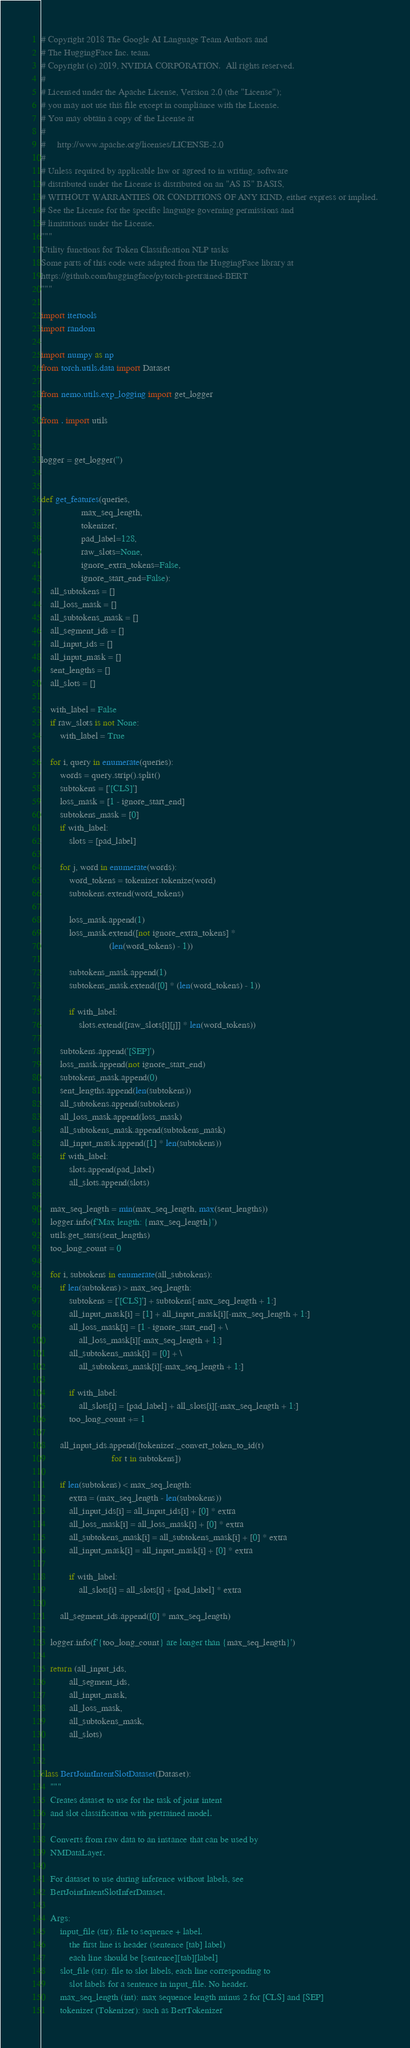<code> <loc_0><loc_0><loc_500><loc_500><_Python_># Copyright 2018 The Google AI Language Team Authors and
# The HuggingFace Inc. team.
# Copyright (c) 2019, NVIDIA CORPORATION.  All rights reserved.
#
# Licensed under the Apache License, Version 2.0 (the "License");
# you may not use this file except in compliance with the License.
# You may obtain a copy of the License at
#
#     http://www.apache.org/licenses/LICENSE-2.0
#
# Unless required by applicable law or agreed to in writing, software
# distributed under the License is distributed on an "AS IS" BASIS,
# WITHOUT WARRANTIES OR CONDITIONS OF ANY KIND, either express or implied.
# See the License for the specific language governing permissions and
# limitations under the License.
"""
Utility functions for Token Classification NLP tasks
Some parts of this code were adapted from the HuggingFace library at
https://github.com/huggingface/pytorch-pretrained-BERT
"""

import itertools
import random

import numpy as np
from torch.utils.data import Dataset

from nemo.utils.exp_logging import get_logger

from . import utils


logger = get_logger('')


def get_features(queries,
                 max_seq_length,
                 tokenizer,
                 pad_label=128,
                 raw_slots=None,
                 ignore_extra_tokens=False,
                 ignore_start_end=False):
    all_subtokens = []
    all_loss_mask = []
    all_subtokens_mask = []
    all_segment_ids = []
    all_input_ids = []
    all_input_mask = []
    sent_lengths = []
    all_slots = []

    with_label = False
    if raw_slots is not None:
        with_label = True

    for i, query in enumerate(queries):
        words = query.strip().split()
        subtokens = ['[CLS]']
        loss_mask = [1 - ignore_start_end]
        subtokens_mask = [0]
        if with_label:
            slots = [pad_label]

        for j, word in enumerate(words):
            word_tokens = tokenizer.tokenize(word)
            subtokens.extend(word_tokens)

            loss_mask.append(1)
            loss_mask.extend([not ignore_extra_tokens] *
                             (len(word_tokens) - 1))

            subtokens_mask.append(1)
            subtokens_mask.extend([0] * (len(word_tokens) - 1))

            if with_label:
                slots.extend([raw_slots[i][j]] * len(word_tokens))

        subtokens.append('[SEP]')
        loss_mask.append(not ignore_start_end)
        subtokens_mask.append(0)
        sent_lengths.append(len(subtokens))
        all_subtokens.append(subtokens)
        all_loss_mask.append(loss_mask)
        all_subtokens_mask.append(subtokens_mask)
        all_input_mask.append([1] * len(subtokens))
        if with_label:
            slots.append(pad_label)
            all_slots.append(slots)

    max_seq_length = min(max_seq_length, max(sent_lengths))
    logger.info(f'Max length: {max_seq_length}')
    utils.get_stats(sent_lengths)
    too_long_count = 0

    for i, subtokens in enumerate(all_subtokens):
        if len(subtokens) > max_seq_length:
            subtokens = ['[CLS]'] + subtokens[-max_seq_length + 1:]
            all_input_mask[i] = [1] + all_input_mask[i][-max_seq_length + 1:]
            all_loss_mask[i] = [1 - ignore_start_end] + \
                all_loss_mask[i][-max_seq_length + 1:]
            all_subtokens_mask[i] = [0] + \
                all_subtokens_mask[i][-max_seq_length + 1:]

            if with_label:
                all_slots[i] = [pad_label] + all_slots[i][-max_seq_length + 1:]
            too_long_count += 1

        all_input_ids.append([tokenizer._convert_token_to_id(t)
                              for t in subtokens])

        if len(subtokens) < max_seq_length:
            extra = (max_seq_length - len(subtokens))
            all_input_ids[i] = all_input_ids[i] + [0] * extra
            all_loss_mask[i] = all_loss_mask[i] + [0] * extra
            all_subtokens_mask[i] = all_subtokens_mask[i] + [0] * extra
            all_input_mask[i] = all_input_mask[i] + [0] * extra

            if with_label:
                all_slots[i] = all_slots[i] + [pad_label] * extra

        all_segment_ids.append([0] * max_seq_length)

    logger.info(f'{too_long_count} are longer than {max_seq_length}')

    return (all_input_ids,
            all_segment_ids,
            all_input_mask,
            all_loss_mask,
            all_subtokens_mask,
            all_slots)


class BertJointIntentSlotDataset(Dataset):
    """
    Creates dataset to use for the task of joint intent
    and slot classification with pretrained model.

    Converts from raw data to an instance that can be used by
    NMDataLayer.

    For dataset to use during inference without labels, see
    BertJointIntentSlotInferDataset.

    Args:
        input_file (str): file to sequence + label.
            the first line is header (sentence [tab] label)
            each line should be [sentence][tab][label]
        slot_file (str): file to slot labels, each line corresponding to
            slot labels for a sentence in input_file. No header.
        max_seq_length (int): max sequence length minus 2 for [CLS] and [SEP]
        tokenizer (Tokenizer): such as BertTokenizer</code> 